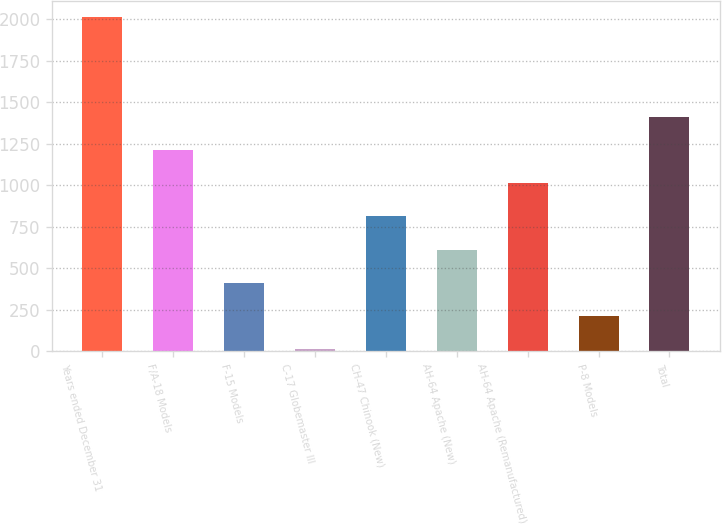Convert chart. <chart><loc_0><loc_0><loc_500><loc_500><bar_chart><fcel>Years ended December 31<fcel>F/A-18 Models<fcel>F-15 Models<fcel>C-17 Globemaster III<fcel>CH-47 Chinook (New)<fcel>AH-64 Apache (New)<fcel>AH-64 Apache (Remanufactured)<fcel>P-8 Models<fcel>Total<nl><fcel>2013<fcel>1211.8<fcel>410.6<fcel>10<fcel>811.2<fcel>610.9<fcel>1011.5<fcel>210.3<fcel>1412.1<nl></chart> 